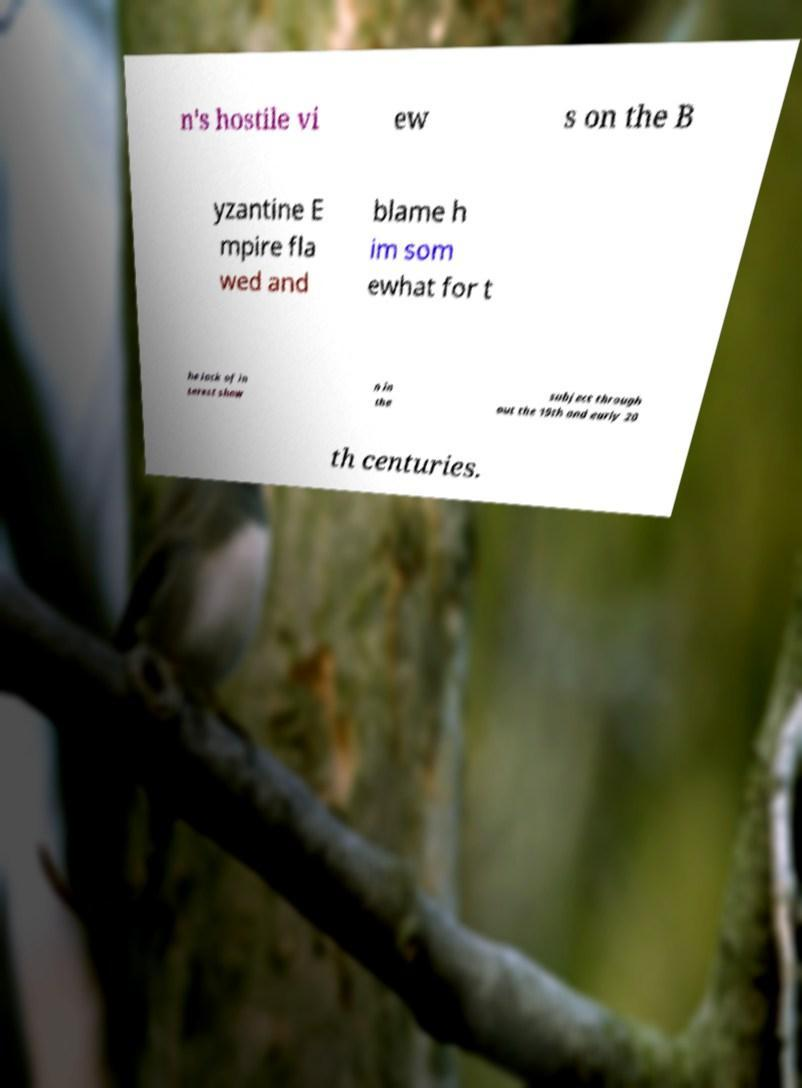Can you read and provide the text displayed in the image?This photo seems to have some interesting text. Can you extract and type it out for me? n's hostile vi ew s on the B yzantine E mpire fla wed and blame h im som ewhat for t he lack of in terest show n in the subject through out the 19th and early 20 th centuries. 